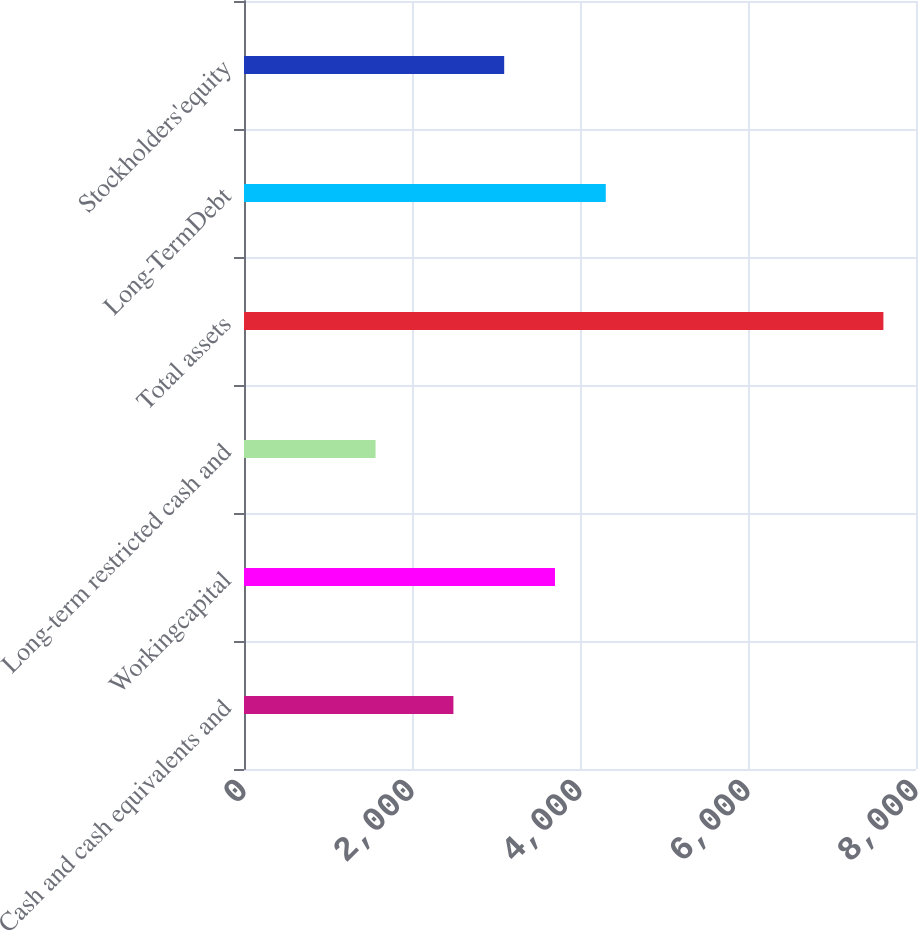Convert chart to OTSL. <chart><loc_0><loc_0><loc_500><loc_500><bar_chart><fcel>Cash and cash equivalents and<fcel>Workingcapital<fcel>Long-term restricted cash and<fcel>Total assets<fcel>Long-TermDebt<fcel>Stockholders'equity<nl><fcel>2493<fcel>3702.2<fcel>1566<fcel>7612<fcel>4306.8<fcel>3097.6<nl></chart> 